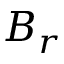Convert formula to latex. <formula><loc_0><loc_0><loc_500><loc_500>B _ { r }</formula> 